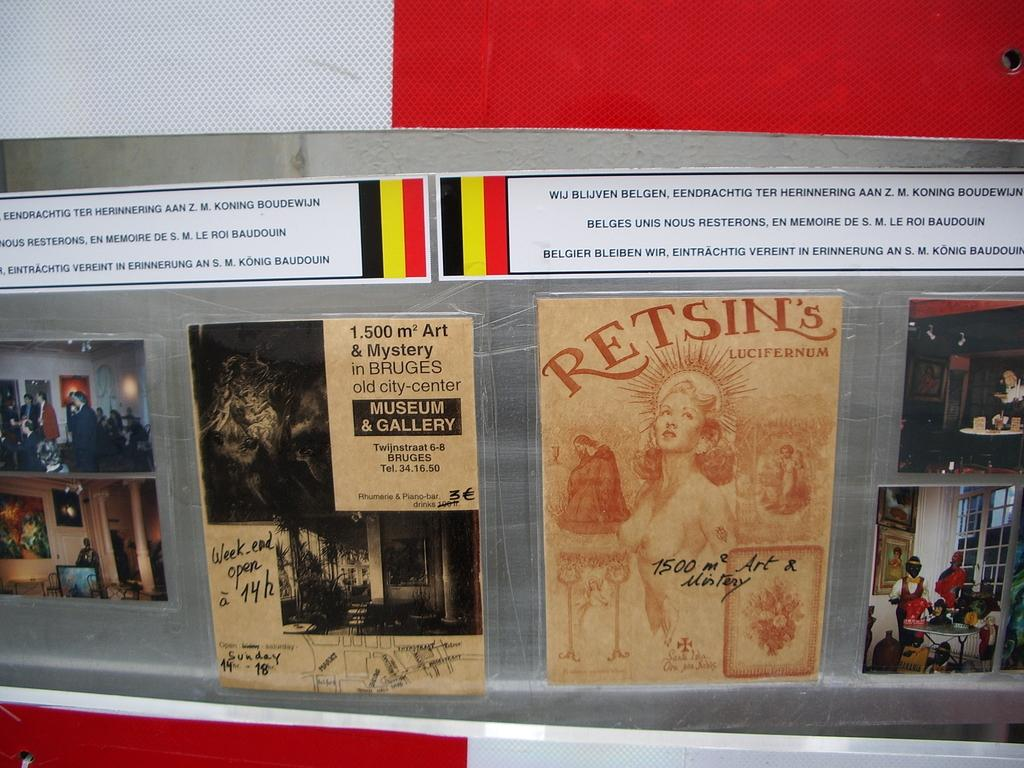<image>
Write a terse but informative summary of the picture. Display of several posters in another language with one reading Retsins. 